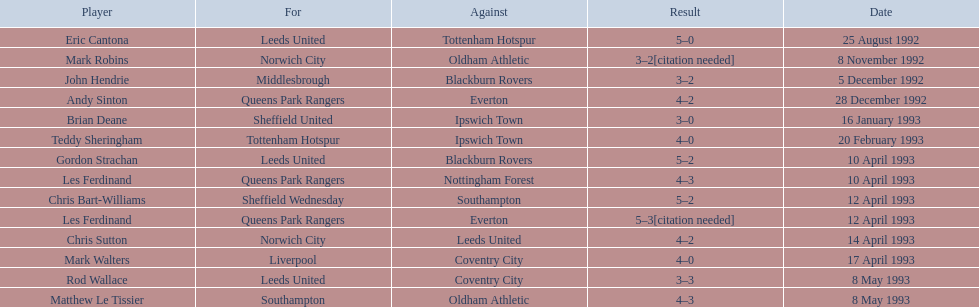What are the findings? 5–0, 3–2[citation needed], 3–2, 4–2, 3–0, 4–0, 5–2, 4–3, 5–2, 5–3[citation needed], 4–2, 4–0, 3–3, 4–3. What finding did mark robins get? 3–2[citation needed]. What other player got that finding? John Hendrie. 